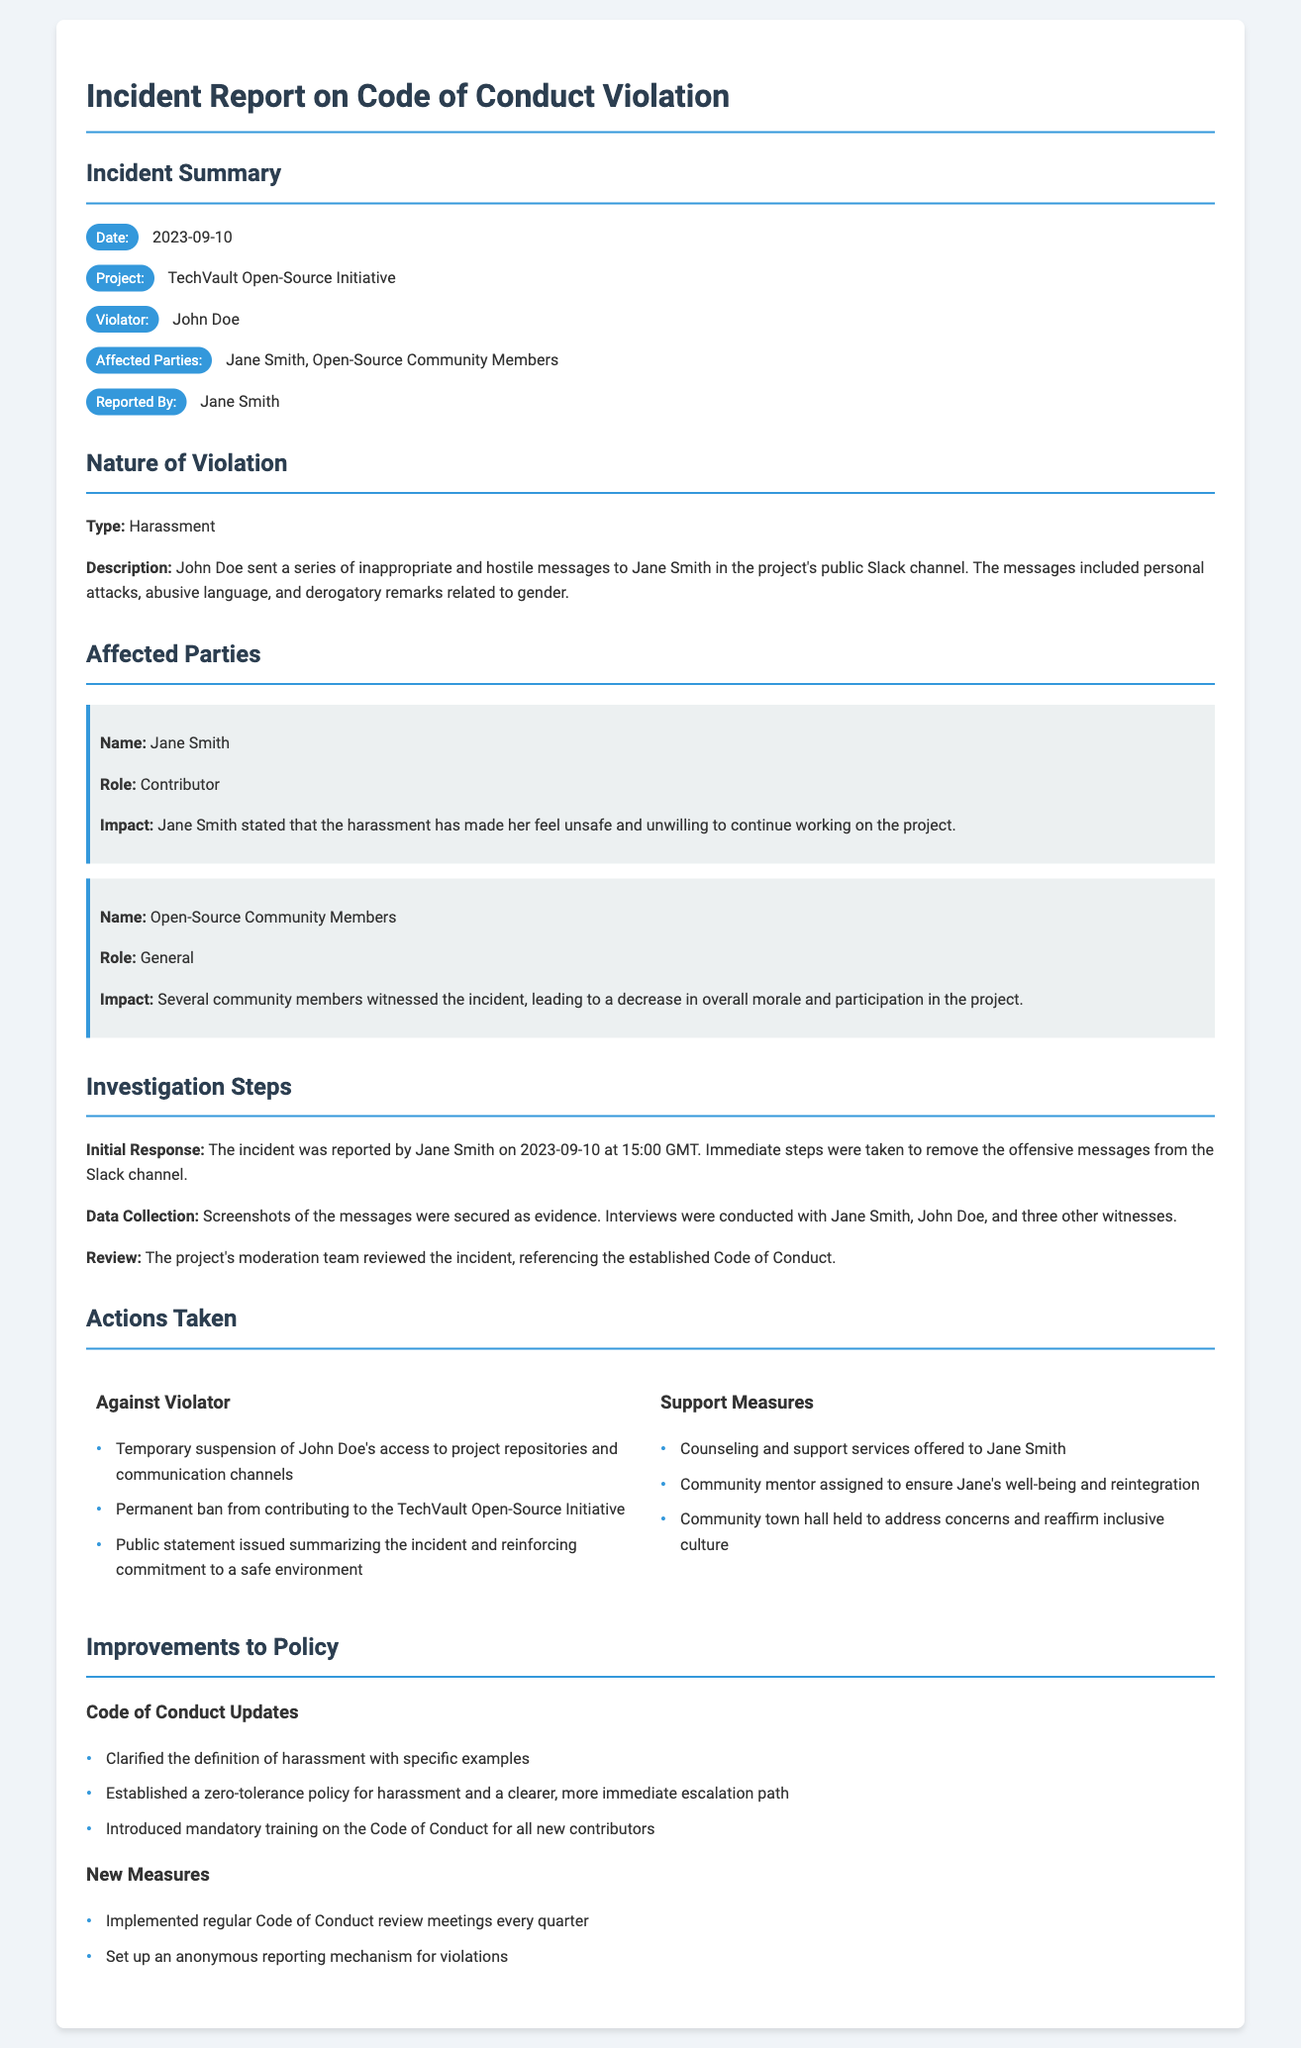What is the date of the incident? The date is the specific day when the incident occurred, which is noted in the document.
Answer: 2023-09-10 Who was the violator in this incident? The violator is the individual who committed the act leading to the code of conduct violation.
Answer: John Doe What type of violation occurred in this incident? The type of violation identifies the nature of the inappropriate behavior, as specified in the document.
Answer: Harassment Who reported the incident? The reporter is the person who brought the violation to attention, detailed in the document.
Answer: Jane Smith What were the initial steps taken during the investigation? The initial steps outline the immediate actions performed in response to the reported violation, as recorded.
Answer: Immediate steps were taken to remove the offensive messages from the Slack channel What action was taken against the violator? The action taken denotes the punishment or consequence imposed on the violator for their actions.
Answer: Permanent ban from contributing to the TechVault Open-Source Initiative What support was provided to Jane Smith? This question addresses the measures taken to assist the affected party after the incident.
Answer: Counseling and support services offered to Jane Smith What improvements were made to the Code of Conduct? This question targets the updates or changes to the Code of Conduct in response to the incident, as mentioned in the document.
Answer: Clarified the definition of harassment with specific examples How frequently will Code of Conduct review meetings be held? The frequency indicates how often the community will revisit the policies to ensure effectiveness, according to the new measures in the report.
Answer: Every quarter 